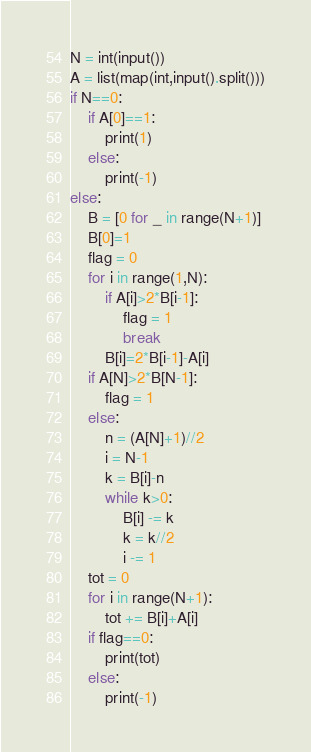Convert code to text. <code><loc_0><loc_0><loc_500><loc_500><_Python_>N = int(input())
A = list(map(int,input().split()))
if N==0:
    if A[0]==1:
        print(1)
    else:
        print(-1)
else:
    B = [0 for _ in range(N+1)]
    B[0]=1
    flag = 0
    for i in range(1,N):
        if A[i]>2*B[i-1]:
            flag = 1
            break
        B[i]=2*B[i-1]-A[i]
    if A[N]>2*B[N-1]:
        flag = 1
    else:
        n = (A[N]+1)//2
        i = N-1
        k = B[i]-n
        while k>0:
            B[i] -= k
            k = k//2
            i -= 1
    tot = 0
    for i in range(N+1):
        tot += B[i]+A[i]
    if flag==0:
        print(tot)
    else:
        print(-1)</code> 